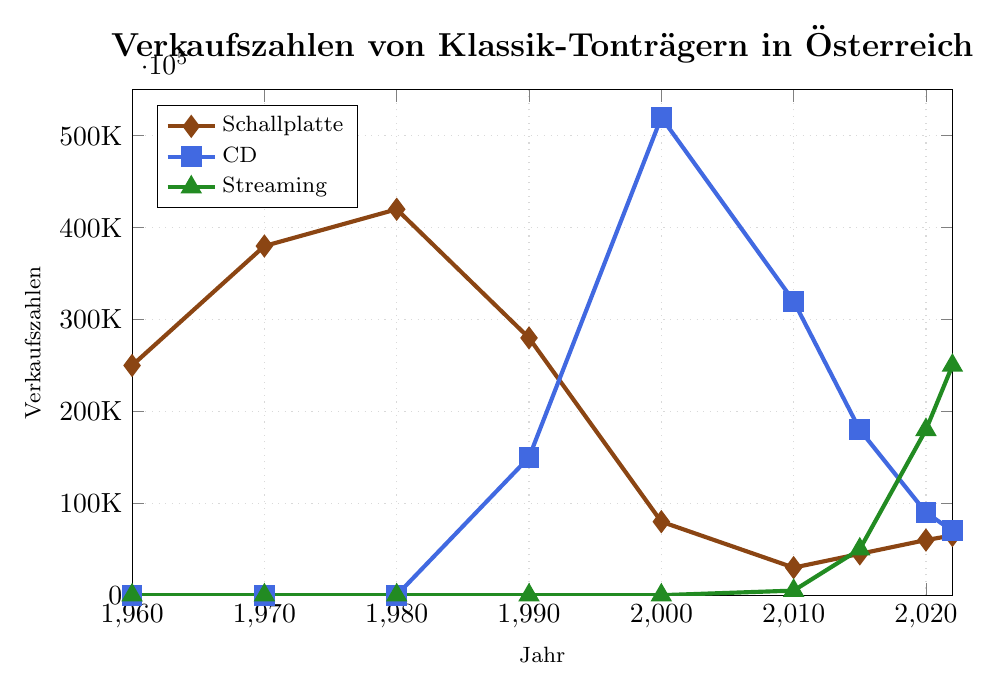What's the trend of Schallplatte sales from 1960 to 2022? Schallplatte sales peaked in 1980 and then started to decline significantly, reaching a low point in 2010. After 2010, there is a slight recovery until 2022.
Answer: Decline Which format had the highest sales in the year 2000? In the year 2000, CD sales were higher than both Schallplatte and Streaming, with a notable margin.
Answer: CD By how much did Streaming sales increase from 2010 to 2022? Streaming sales increased from 5000 in 2010 to 250000 in 2022. The increase is calculated as \(250000 - 5000\).
Answer: 245000 In which year did CD sales reach their peak according to the figure? CD sales reached their peak in the year 2000.
Answer: 2000 Compare the sales of Schallplatte and Streaming in the year 2020. Which one is higher, and by how much? In 2020, Schallplatte sales were 60000, and Streaming sales were 180000. Streaming sales were higher by \(180000 - 60000\).
Answer: Streaming by 120000 How do the sales of Schallplatte in 1980 compare with CD sales at their peak? Schallplatte sales in 1980 were 420000, and CD sales at their peak (2000) were 520000. CD sales exceeded Schallplatte sales by \(520000 - 420000\).
Answer: CD by 100000 What is the overall trend for CD sales from 1990 to 2022? CD sales increased dramatically from 1990 to 2000, then declined consistently from 2000 to 2022.
Answer: Increase followed by a decline What is the combined sales of all formats in the year 2022? In 2022, the sales of Schallplatte were 65000, CD were 70000, and Streaming were 250000. The combined sales are calculated as \(65000 + 70000 + 250000\).
Answer: 385000 Which format experienced the largest relative growth between 2010 and 2022? Streaming sales grew from 5000 in 2010 to 250000 in 2022. CD and Schallplatte did not experience such a high relative increase. Relative growth for Streaming is calculated as \((250000 - 5000) / 5000\).
Answer: Streaming How did Schallplatte sales change from 1960 to 1980? Sales of Schallplatte increased from 250000 in 1960 to 420000 in 1980.
Answer: Increased 